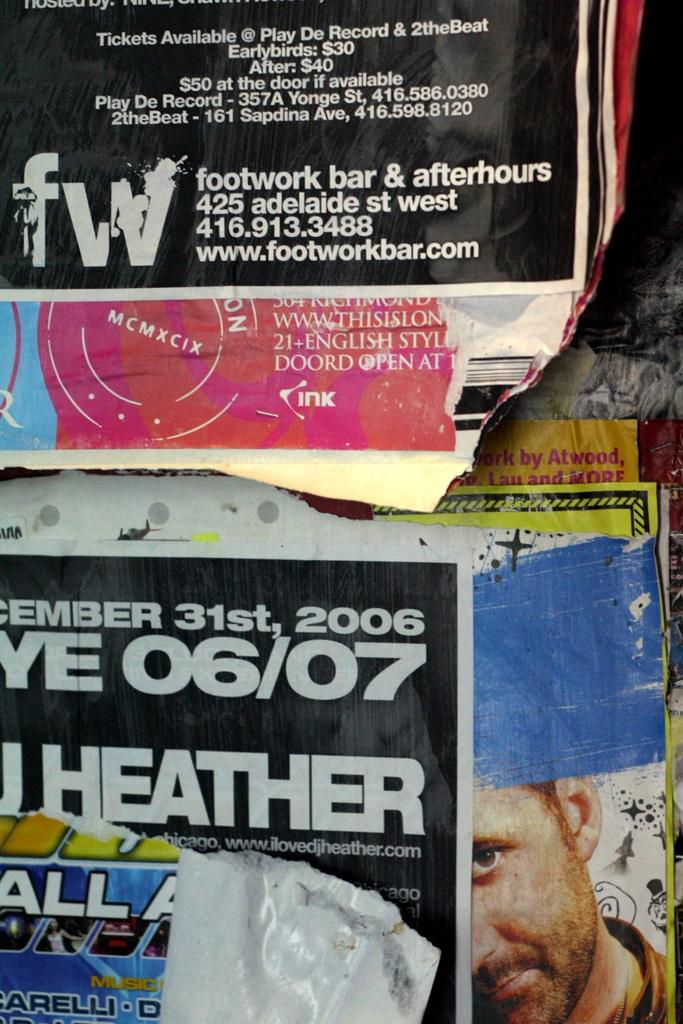What is attached to the wall in the image? There are posters attached to the wall in the image. What else can be seen on the wall besides the posters? There is text and an image of a person on the wall in the image. How many secretaries are present in the image? There is no mention of a secretary in the image; it features posters, text, and an image of a person on the wall. What is the net weight of the image? The image is a digital or physical representation and does not have a net weight. 